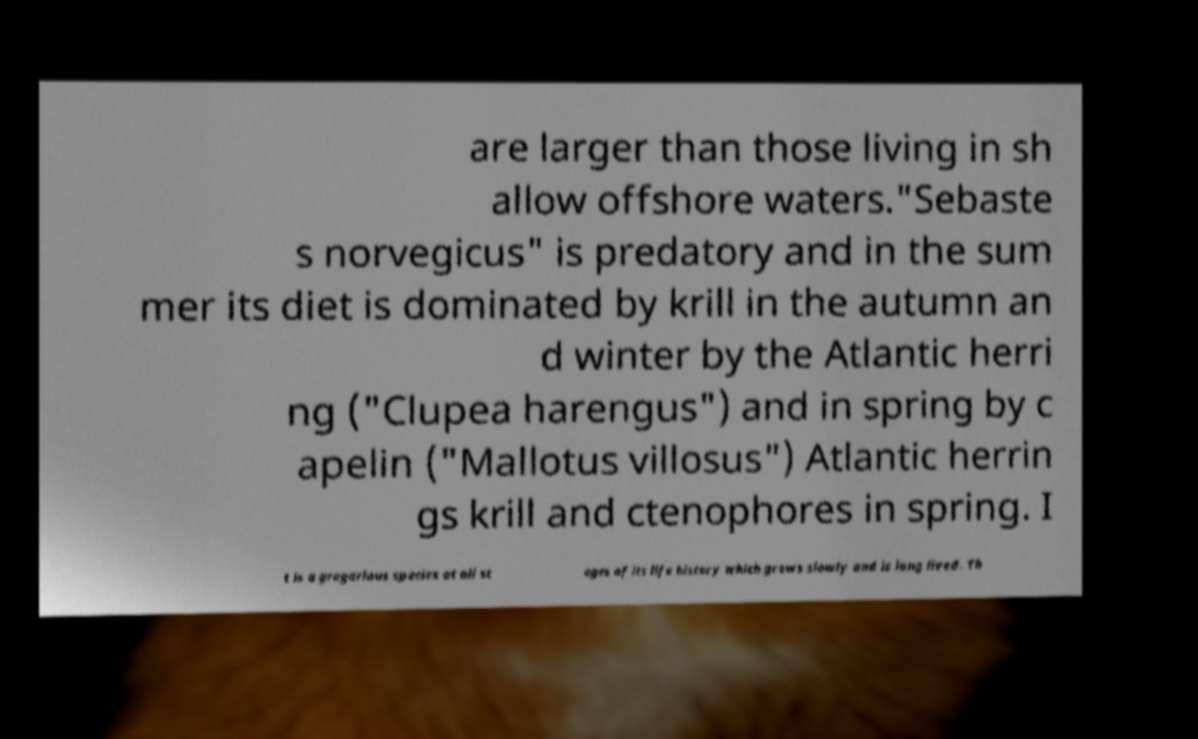Can you accurately transcribe the text from the provided image for me? are larger than those living in sh allow offshore waters."Sebaste s norvegicus" is predatory and in the sum mer its diet is dominated by krill in the autumn an d winter by the Atlantic herri ng ("Clupea harengus") and in spring by c apelin ("Mallotus villosus") Atlantic herrin gs krill and ctenophores in spring. I t is a gregarious species at all st ages of its life history which grows slowly and is long lived. Th 